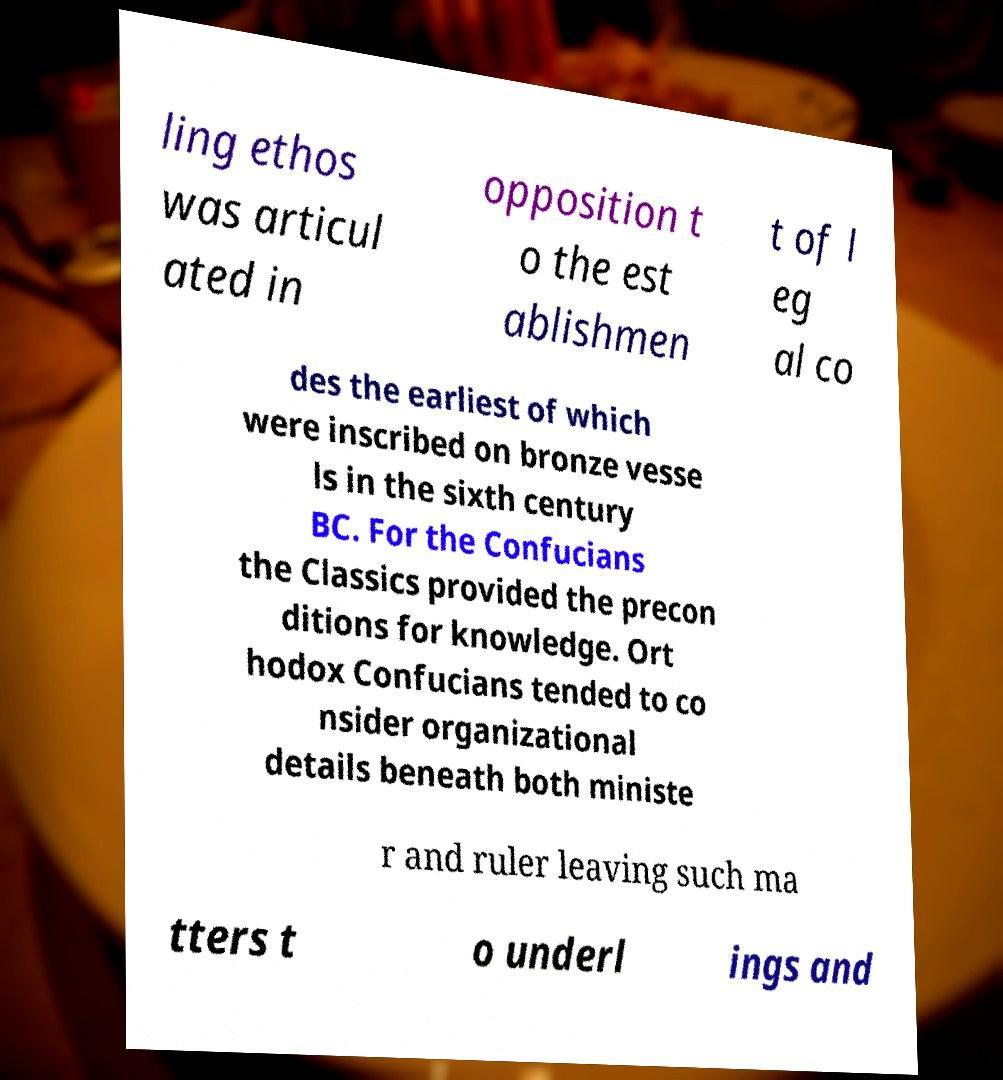Can you read and provide the text displayed in the image?This photo seems to have some interesting text. Can you extract and type it out for me? ling ethos was articul ated in opposition t o the est ablishmen t of l eg al co des the earliest of which were inscribed on bronze vesse ls in the sixth century BC. For the Confucians the Classics provided the precon ditions for knowledge. Ort hodox Confucians tended to co nsider organizational details beneath both ministe r and ruler leaving such ma tters t o underl ings and 